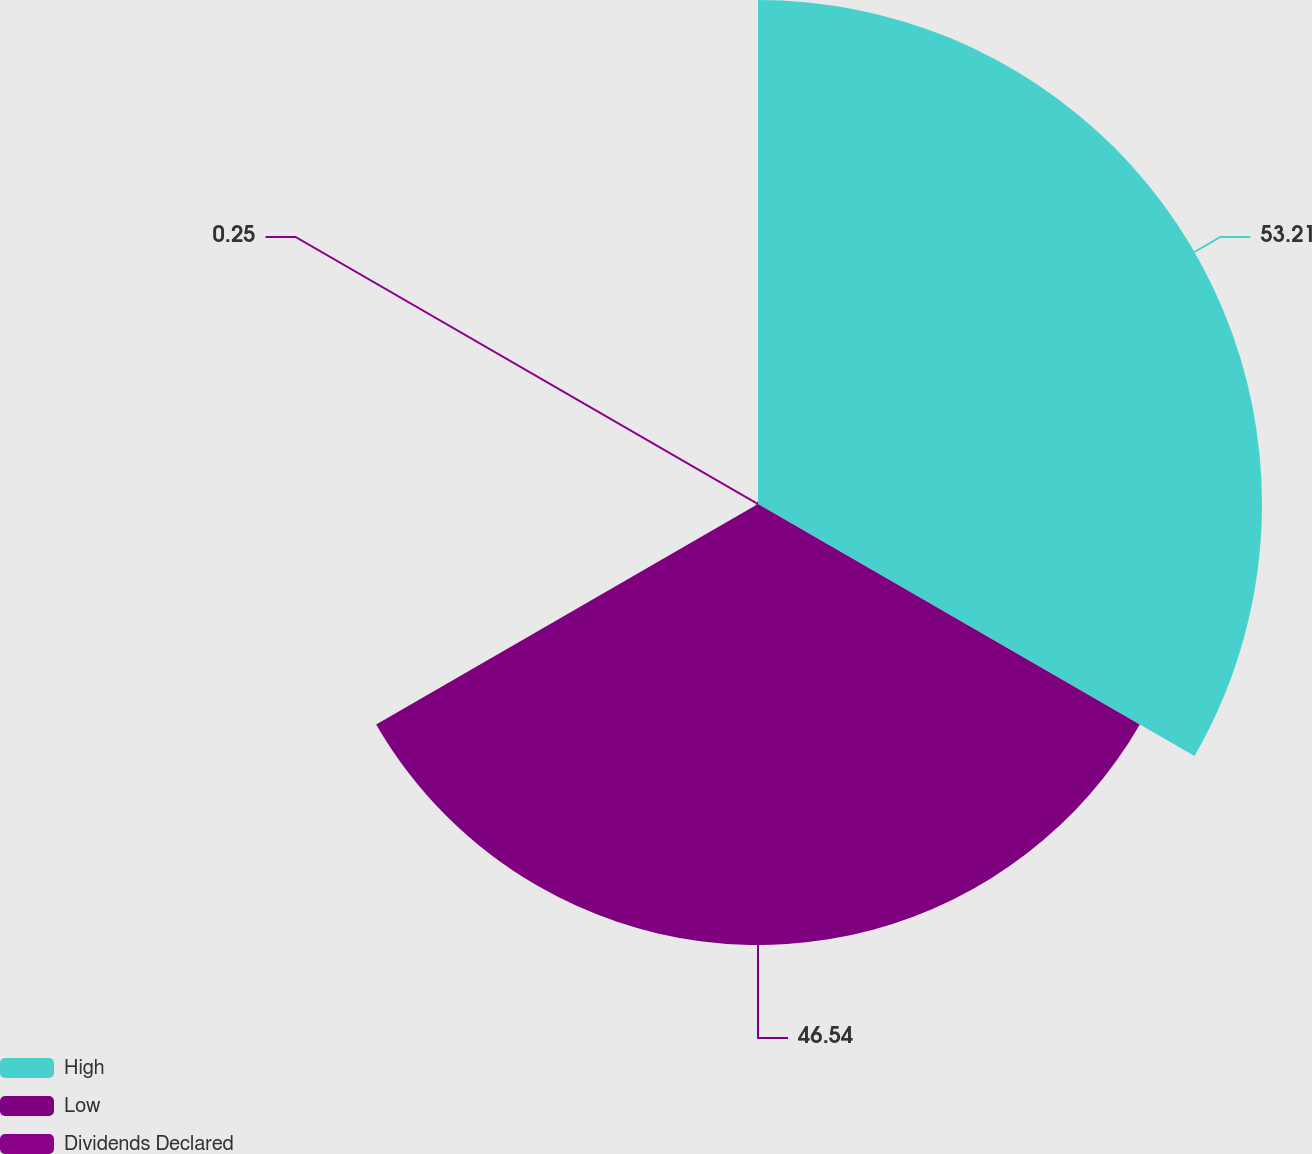Convert chart to OTSL. <chart><loc_0><loc_0><loc_500><loc_500><pie_chart><fcel>High<fcel>Low<fcel>Dividends Declared<nl><fcel>53.2%<fcel>46.54%<fcel>0.25%<nl></chart> 